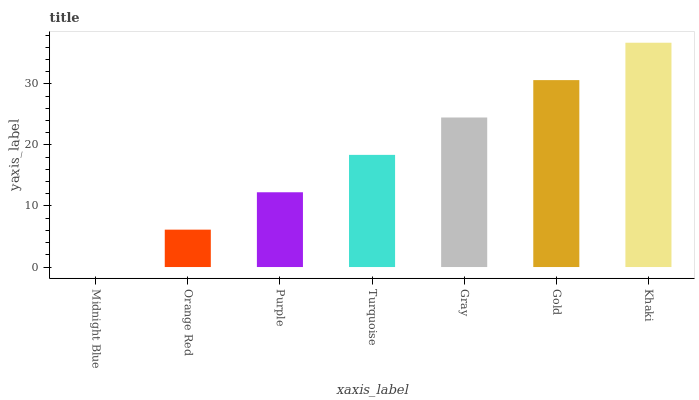Is Midnight Blue the minimum?
Answer yes or no. Yes. Is Khaki the maximum?
Answer yes or no. Yes. Is Orange Red the minimum?
Answer yes or no. No. Is Orange Red the maximum?
Answer yes or no. No. Is Orange Red greater than Midnight Blue?
Answer yes or no. Yes. Is Midnight Blue less than Orange Red?
Answer yes or no. Yes. Is Midnight Blue greater than Orange Red?
Answer yes or no. No. Is Orange Red less than Midnight Blue?
Answer yes or no. No. Is Turquoise the high median?
Answer yes or no. Yes. Is Turquoise the low median?
Answer yes or no. Yes. Is Midnight Blue the high median?
Answer yes or no. No. Is Gray the low median?
Answer yes or no. No. 